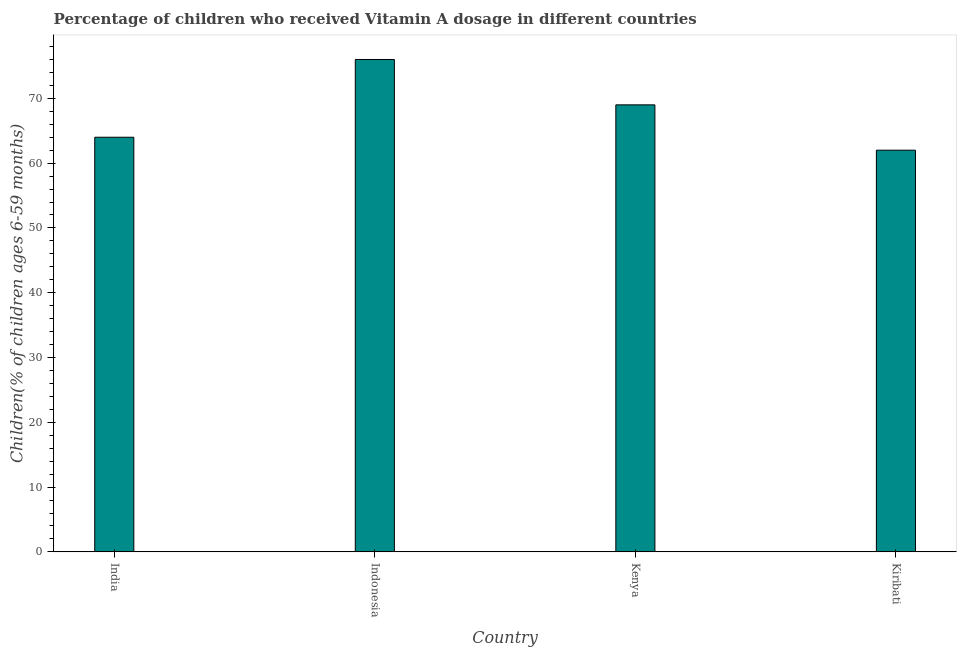Does the graph contain any zero values?
Give a very brief answer. No. Does the graph contain grids?
Give a very brief answer. No. What is the title of the graph?
Provide a short and direct response. Percentage of children who received Vitamin A dosage in different countries. What is the label or title of the Y-axis?
Provide a succinct answer. Children(% of children ages 6-59 months). In which country was the vitamin a supplementation coverage rate minimum?
Offer a very short reply. Kiribati. What is the sum of the vitamin a supplementation coverage rate?
Your answer should be very brief. 271. What is the average vitamin a supplementation coverage rate per country?
Provide a short and direct response. 67.75. What is the median vitamin a supplementation coverage rate?
Offer a terse response. 66.5. What is the ratio of the vitamin a supplementation coverage rate in India to that in Indonesia?
Ensure brevity in your answer.  0.84. What is the difference between the highest and the lowest vitamin a supplementation coverage rate?
Offer a terse response. 14. What is the difference between two consecutive major ticks on the Y-axis?
Ensure brevity in your answer.  10. Are the values on the major ticks of Y-axis written in scientific E-notation?
Your answer should be compact. No. What is the Children(% of children ages 6-59 months) in Kenya?
Give a very brief answer. 69. What is the Children(% of children ages 6-59 months) in Kiribati?
Ensure brevity in your answer.  62. What is the difference between the Children(% of children ages 6-59 months) in India and Kenya?
Give a very brief answer. -5. What is the difference between the Children(% of children ages 6-59 months) in India and Kiribati?
Give a very brief answer. 2. What is the ratio of the Children(% of children ages 6-59 months) in India to that in Indonesia?
Offer a very short reply. 0.84. What is the ratio of the Children(% of children ages 6-59 months) in India to that in Kenya?
Your response must be concise. 0.93. What is the ratio of the Children(% of children ages 6-59 months) in India to that in Kiribati?
Your response must be concise. 1.03. What is the ratio of the Children(% of children ages 6-59 months) in Indonesia to that in Kenya?
Keep it short and to the point. 1.1. What is the ratio of the Children(% of children ages 6-59 months) in Indonesia to that in Kiribati?
Offer a terse response. 1.23. What is the ratio of the Children(% of children ages 6-59 months) in Kenya to that in Kiribati?
Offer a terse response. 1.11. 